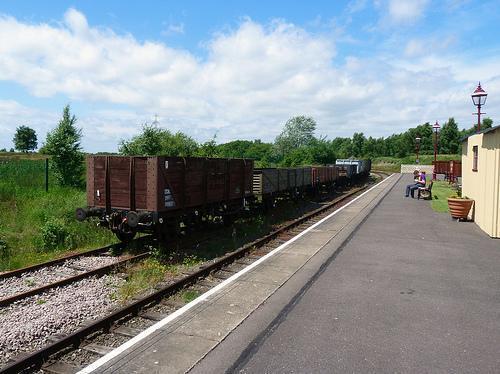How many trains are there?
Give a very brief answer. 1. 